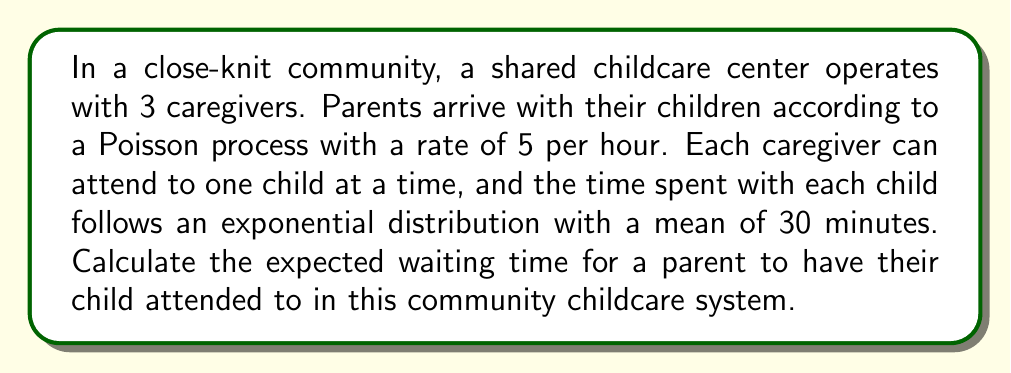Teach me how to tackle this problem. To solve this problem, we'll use the M/M/s queueing model, where M/M indicates Markovian arrival and service processes, and s is the number of servers (caregivers in this case).

Step 1: Define the parameters
- Arrival rate: $\lambda = 5$ per hour
- Service rate per caregiver: $\mu = 2$ per hour (since mean service time is 30 minutes = 1/2 hour)
- Number of caregivers: $s = 3$

Step 2: Calculate the utilization factor $\rho$
$$\rho = \frac{\lambda}{s\mu} = \frac{5}{3 \cdot 2} = \frac{5}{6} \approx 0.833$$

Step 3: Calculate $P_0$, the probability of an empty system
$$P_0 = \left[\sum_{n=0}^{s-1}\frac{(s\rho)^n}{n!} + \frac{(s\rho)^s}{s!(1-\rho)}\right]^{-1}$$
$$P_0 = \left[1 + \frac{5}{1!} + \frac{5^2}{2!} + \frac{5^3}{3!(1-\frac{5}{6})}\right]^{-1} \approx 0.0138$$

Step 4: Calculate $L_q$, the expected number of children waiting in the queue
$$L_q = \frac{P_0(s\rho)^s\rho}{s!(1-\rho)^2} = \frac{0.0138 \cdot 5^3 \cdot \frac{5}{6}}{3!(1-\frac{5}{6})^2} \approx 3.472$$

Step 5: Use Little's Law to calculate $W_q$, the expected waiting time in the queue
$$W_q = \frac{L_q}{\lambda} = \frac{3.472}{5} \approx 0.6944\text{ hours} = 41.664\text{ minutes}$$

This result represents the expected waiting time for a parent to have their child attended to in the community childcare system.
Answer: 41.664 minutes 